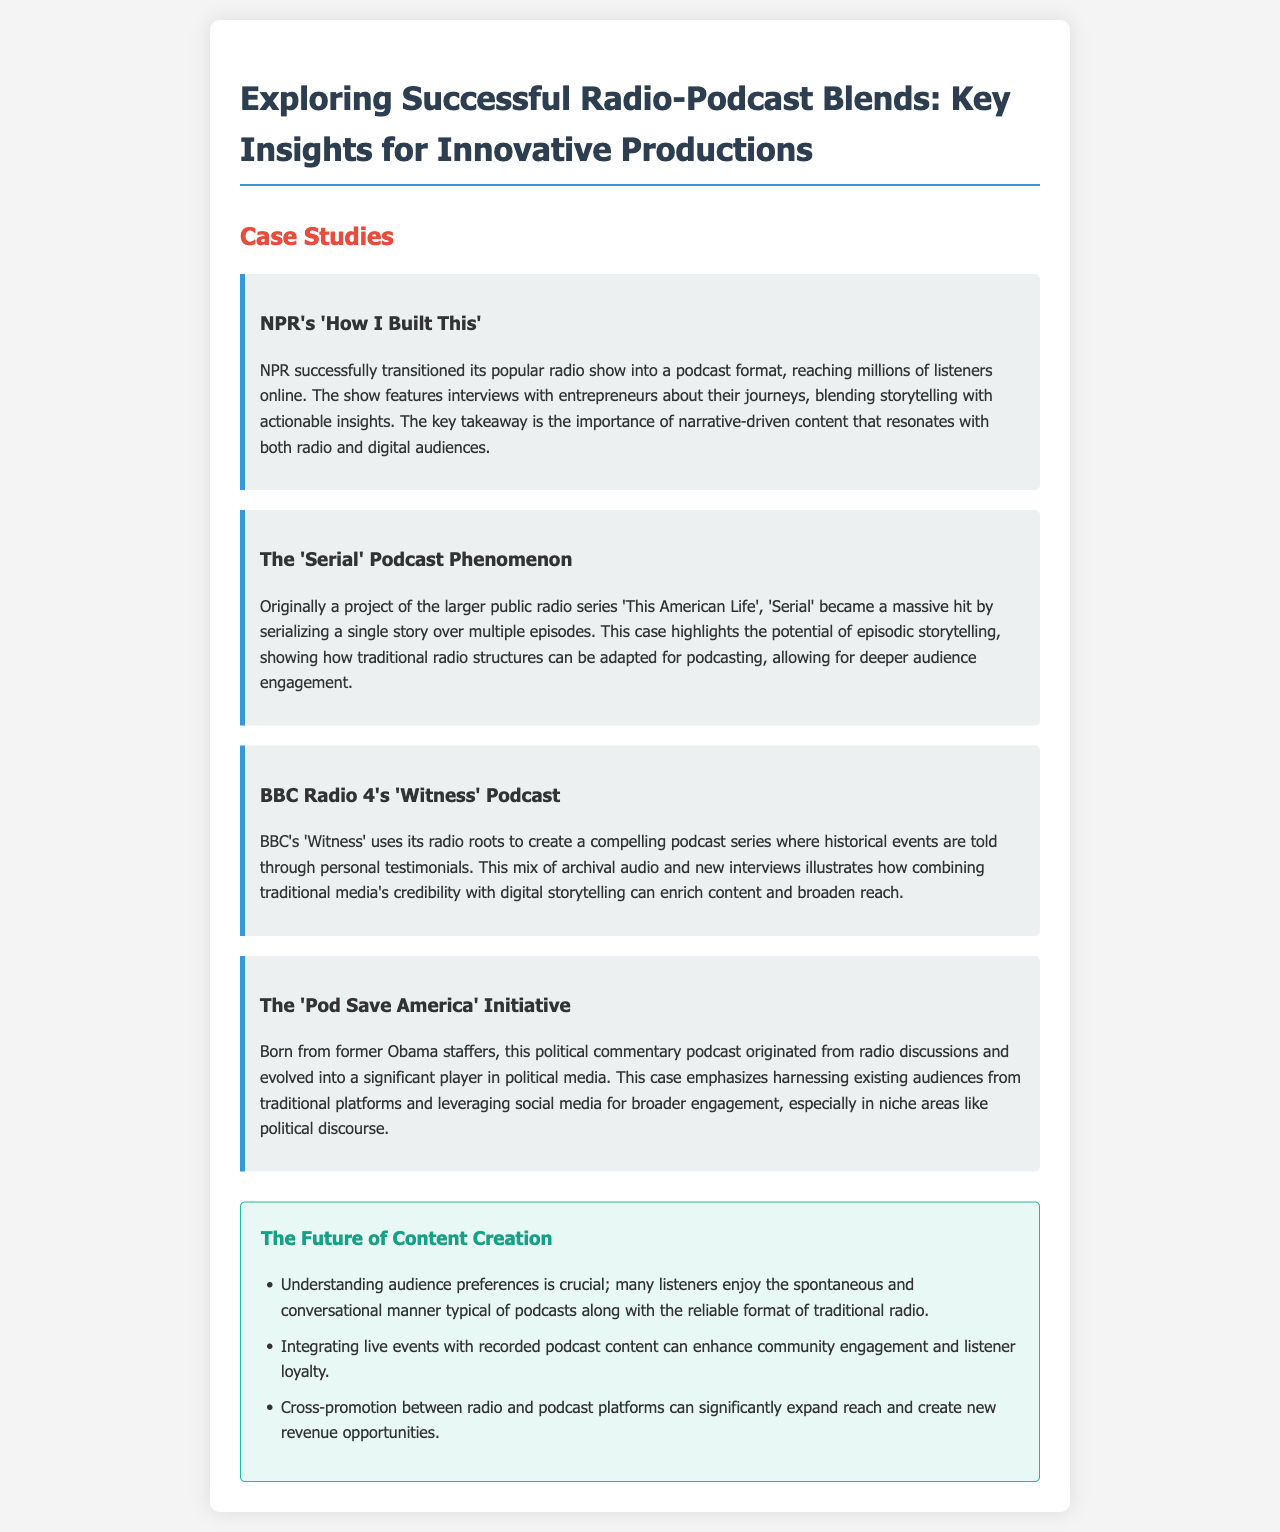What is the title of the first case study? The title of the first case study in the document is about NPR's show.
Answer: NPR's 'How I Built This' What is the main topic of the 'Serial' podcast? The 'Serial' podcast focuses on storytelling by serializing a single story.
Answer: Episodic storytelling What organization created the 'Witness' podcast? The 'Witness' podcast was created by the BBC.
Answer: BBC Radio 4 Who are the founders of the 'Pod Save America' initiative? The founders of the 'Pod Save America' initiative are associated with the Obama administration.
Answer: Former Obama staffers What is a key takeaway regarding audience preferences? The key takeaway discusses listener enjoyment of a specific podcast characteristic.
Answer: Spontaneous and conversational manner How can live events enhance podcasts? The document states that live events can improve a specific aspect of listener engagement.
Answer: Community engagement What is one strategy mentioned for expanding reach? The document mentions a specific strategy for increasing audiences between formats.
Answer: Cross-promotion How does 'Witness' utilize its media roots? It combines archival audio and new interviews to enrich content.
Answer: Combining traditional media's credibility with digital storytelling What is the significance of narrative-driven content? The content resonates with audiences from both radio and digital platforms.
Answer: Importance of narrative-driven content 